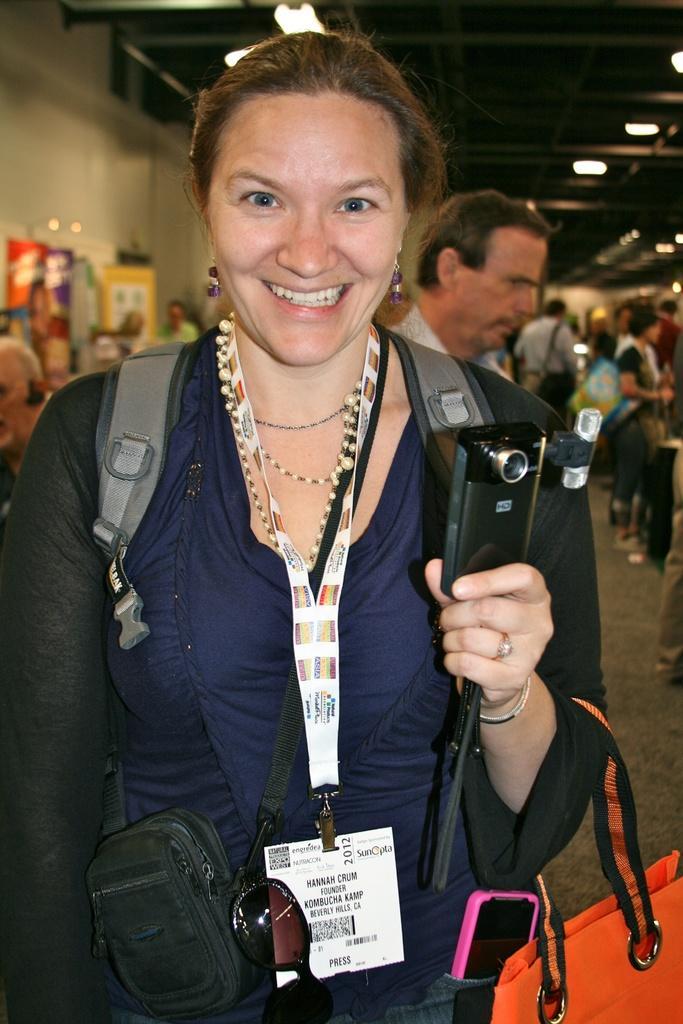Describe this image in one or two sentences. In this image I see a woman who is carrying bags and she is holding a camera in her hand, I also see that she is smiling. In the background I see there are lot of people and the lights. 